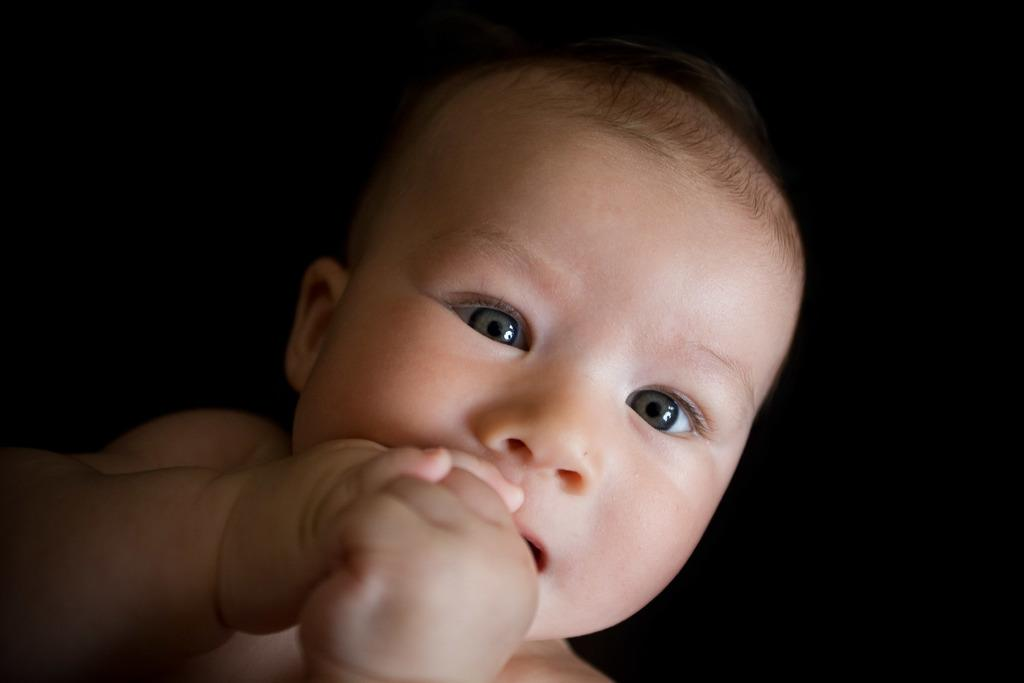What is the main subject of the image? The main subject of the image is a baby. What can be seen in the background of the image? The background of the image is black. What type of jewel is the baby wearing in the image? There is no indication in the image that the baby is wearing any jewel. 